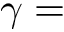Convert formula to latex. <formula><loc_0><loc_0><loc_500><loc_500>\gamma =</formula> 